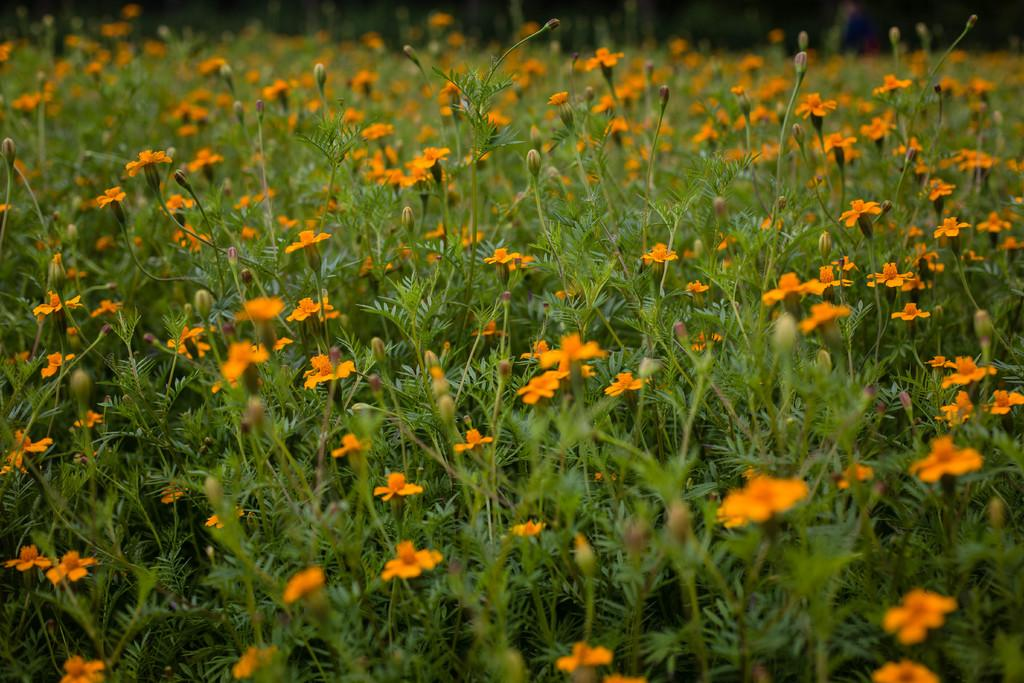What types of living organisms can be seen in the image? Plants and flowers are visible in the image. Where are the plants and flowers located in the image? Both elements are located at the bottom of the image. What type of cake is being suggested in the image? There is no cake present in the image, and therefore no suggestion can be made. 